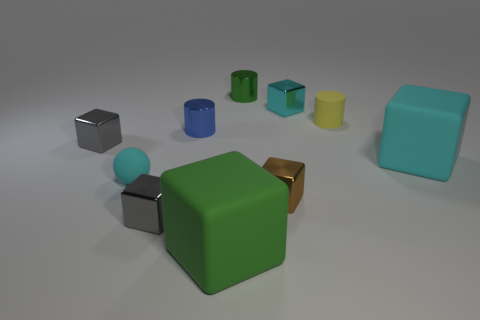Does the tiny cyan thing that is on the right side of the ball have the same material as the brown cube?
Your answer should be compact. Yes. Is the shape of the cyan metal thing the same as the tiny brown thing?
Keep it short and to the point. Yes. What shape is the large matte object in front of the tiny gray cube in front of the gray object that is behind the matte ball?
Give a very brief answer. Cube. Does the tiny cyan thing to the left of the green cylinder have the same shape as the green object behind the brown object?
Offer a very short reply. No. Are there any yellow cylinders that have the same material as the small green thing?
Keep it short and to the point. No. There is a small matte thing that is to the right of the green metallic object that is behind the tiny metallic cylinder that is left of the green cube; what is its color?
Offer a very short reply. Yellow. Is the material of the cyan block in front of the blue shiny thing the same as the small sphere behind the tiny brown metallic cube?
Keep it short and to the point. Yes. What is the shape of the small cyan thing that is left of the brown metallic object?
Your answer should be compact. Sphere. How many objects are either cyan metal objects or small metallic cubes that are right of the cyan rubber sphere?
Offer a very short reply. 3. Is the small blue cylinder made of the same material as the small green cylinder?
Offer a very short reply. Yes. 